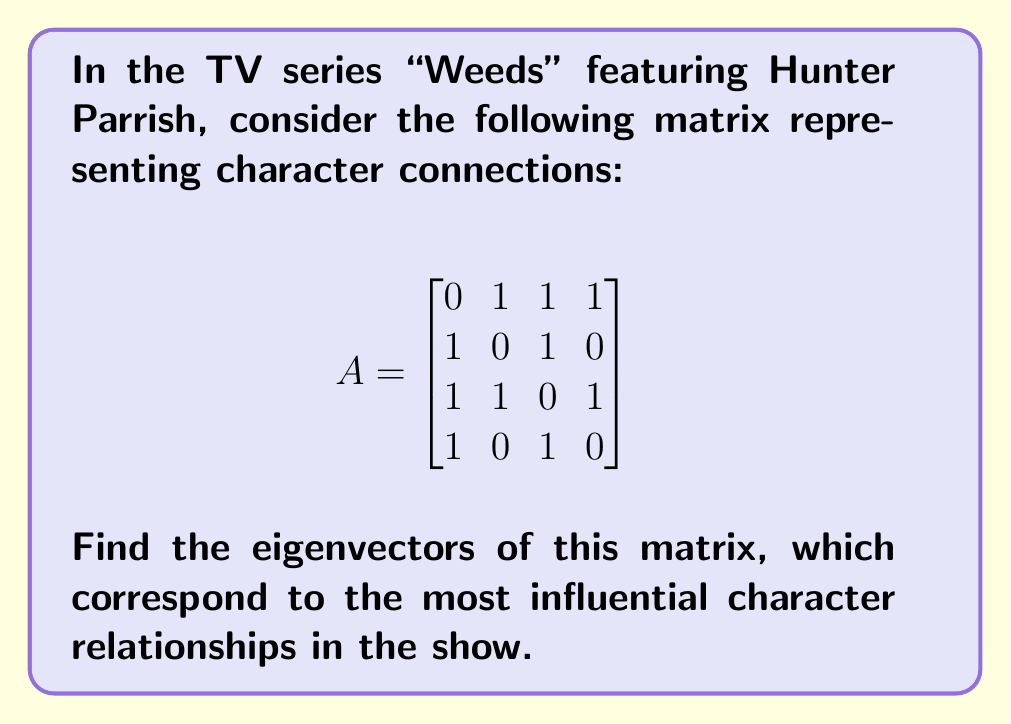Solve this math problem. To find the eigenvectors, we follow these steps:

1) First, we need to find the eigenvalues by solving the characteristic equation:
   $$det(A - \lambda I) = 0$$

2) Expanding the determinant:
   $$\begin{vmatrix}
   -\lambda & 1 & 1 & 1 \\
   1 & -\lambda & 1 & 0 \\
   1 & 1 & -\lambda & 1 \\
   1 & 0 & 1 & -\lambda
   \end{vmatrix} = 0$$

3) This yields the characteristic polynomial:
   $$\lambda^4 - 3\lambda^2 - 2\lambda + 1 = 0$$

4) Solving this equation gives us the eigenvalues:
   $$\lambda_1 = -1, \lambda_2 = 1, \lambda_3 = 2, \lambda_4 = -1$$

5) For each eigenvalue, we solve $(A - \lambda I)v = 0$ to find the corresponding eigenvector:

   For $\lambda_1 = \lambda_4 = -1$:
   $$\begin{bmatrix}
   1 & 1 & 1 & 1 \\
   1 & 1 & 1 & 0 \\
   1 & 1 & 1 & 1 \\
   1 & 0 & 1 & 1
   \end{bmatrix} \begin{bmatrix} v_1 \\ v_2 \\ v_3 \\ v_4 \end{bmatrix} = \begin{bmatrix} 0 \\ 0 \\ 0 \\ 0 \end{bmatrix}$$
   This gives us: $v_1 = [-1, 1, 0, 0]^T$ and $v_2 = [0, -1, 0, 1]^T$

   For $\lambda_2 = 1$:
   $$\begin{bmatrix}
   -1 & 1 & 1 & 1 \\
   1 & -1 & 1 & 0 \\
   1 & 1 & -1 & 1 \\
   1 & 0 & 1 & -1
   \end{bmatrix} \begin{bmatrix} v_1 \\ v_2 \\ v_3 \\ v_4 \end{bmatrix} = \begin{bmatrix} 0 \\ 0 \\ 0 \\ 0 \end{bmatrix}$$
   This gives us: $v_3 = [1, 1, 1, 1]^T$

   For $\lambda_3 = 2$:
   $$\begin{bmatrix}
   -2 & 1 & 1 & 1 \\
   1 & -2 & 1 & 0 \\
   1 & 1 & -2 & 1 \\
   1 & 0 & 1 & -2
   \end{bmatrix} \begin{bmatrix} v_1 \\ v_2 \\ v_3 \\ v_4 \end{bmatrix} = \begin{bmatrix} 0 \\ 0 \\ 0 \\ 0 \end{bmatrix}$$
   This gives us: $v_4 = [1, -1, 1, -1]^T$
Answer: $v_1 = [-1, 1, 0, 0]^T$, $v_2 = [0, -1, 0, 1]^T$, $v_3 = [1, 1, 1, 1]^T$, $v_4 = [1, -1, 1, -1]^T$ 